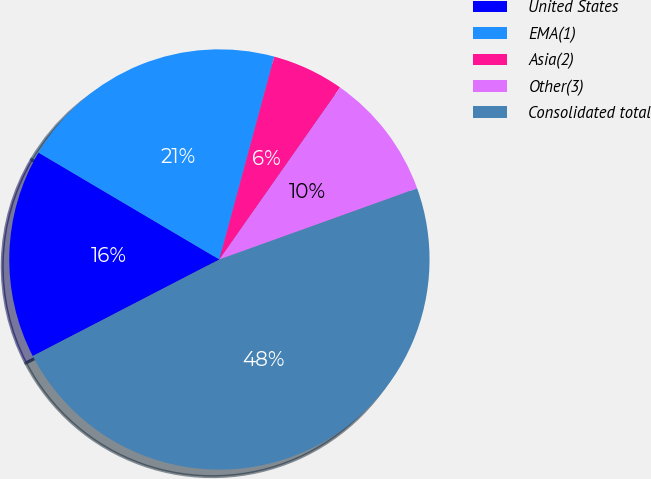Convert chart to OTSL. <chart><loc_0><loc_0><loc_500><loc_500><pie_chart><fcel>United States<fcel>EMA(1)<fcel>Asia(2)<fcel>Other(3)<fcel>Consolidated total<nl><fcel>16.1%<fcel>20.71%<fcel>5.53%<fcel>9.77%<fcel>47.89%<nl></chart> 